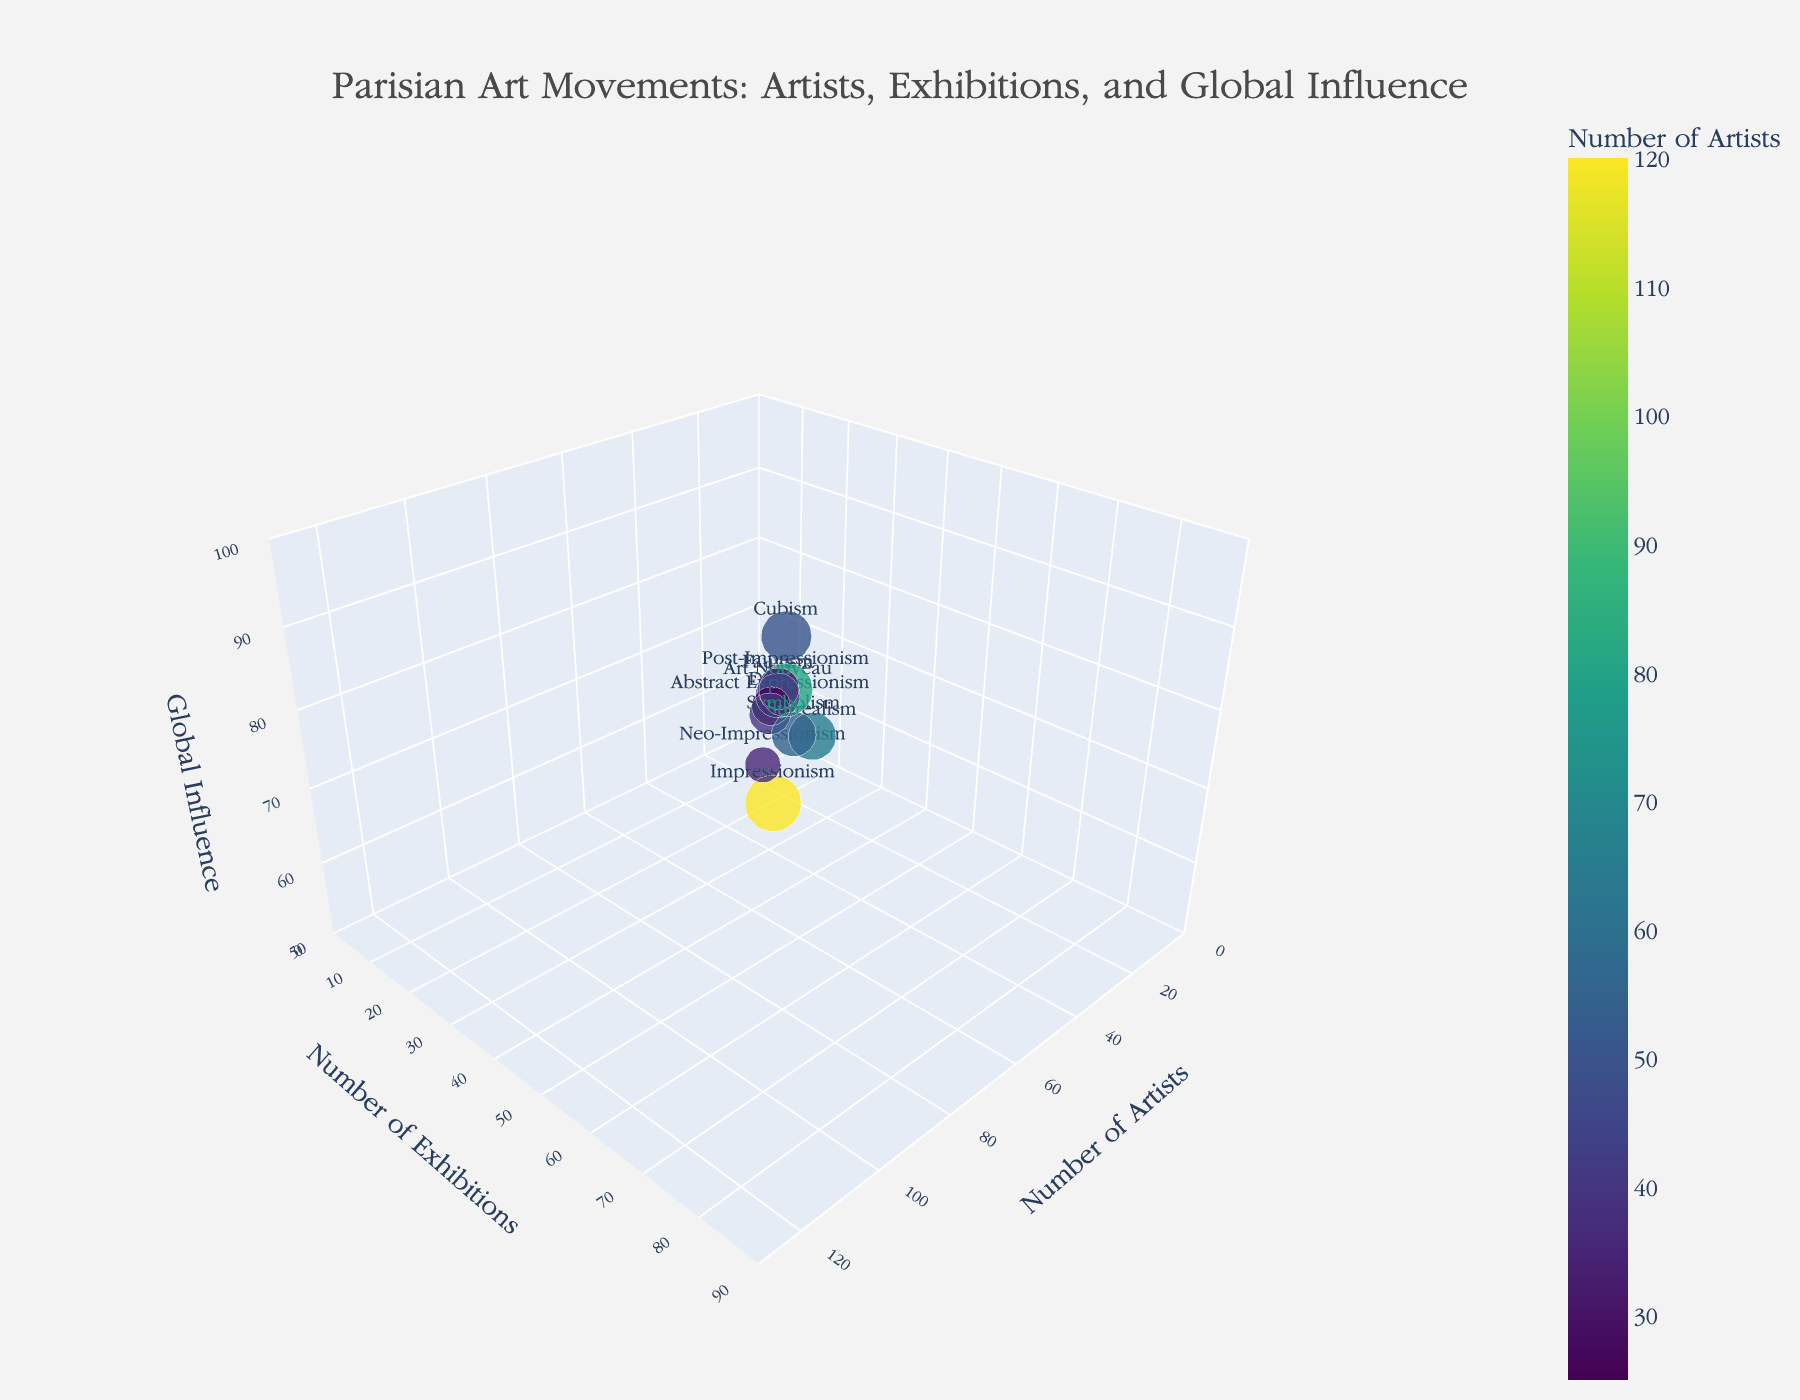What's the title of the figure? The title is typically placed at the top of the figure, making it one of the most prominent text elements. By looking at the top of the figure, the title "Parisian Art Movements: Artists, Exhibitions, and Global Influence" is clearly visible.
Answer: Parisian Art Movements: Artists, Exhibitions, and Global Influence How many movements have more than 50 exhibitions? By analyzing the y-axis, which represents the number of exhibitions, and looking for data points above the 50 mark, three movements surpass this threshold: Impressionism, Surrealism, and Symbolism.
Answer: Three Which movement has the highest number of artists? By examining the x-axis, which denotes the number of artists, we identify the movement with the highest x-value. Impressionism has the highest number of artists at 120.
Answer: Impressionism What is the global influence range among all movements? The z-axis shows global influence, ranging from the minimum value of 60 (Neo-Impressionism) to the maximum value of 95 (Impressionism). The difference between these values is the range.
Answer: 35 Compare the number of artists in Cubism and Abstract Expressionism. Which one is greater and by how much? Cubism has 50 artists, while Abstract Expressionism has 40 artists. Subtracting 40 from 50 gives the difference.
Answer: Cubism by 10 What is the total global influence of Impressionism and Post-Impressionism? Adding the global influence values of Impressionism (95) and Post-Impressionism (90) results in 95 + 90.
Answer: 185 Which movement has the smallest bubble in the chart? Bubble size is proportional to global influence divided by 3. The smallest global influence (thus smallest bubble) belongs to Neo-Impressionism with an influence value of 60.
Answer: Neo-Impressionism What is the average number of exhibitions across all movements? Sum the number of exhibitions for all movements and divide by the number of movements: (85 + 60 + 25 + 40 + 55 + 35 + 20 + 30 + 25 + 45) / 10 = 420 / 10.
Answer: 42 Which movement, other than Impressionism, has the highest global influence, and what is its value? Excluding Impressionism, check the z-values to find the highest. Post-Impressionism follows with a global influence of 90.
Answer: Post-Impressionism, 90 What are the y and z values of the point that corresponds to Surrealism? By locating Surrealism on the chart and reading its y-value (number of exhibitions) and z-value (global influence), we find 55 and 80 respectively.
Answer: 55 (Exhibitions) and 80 (Global Influence) 